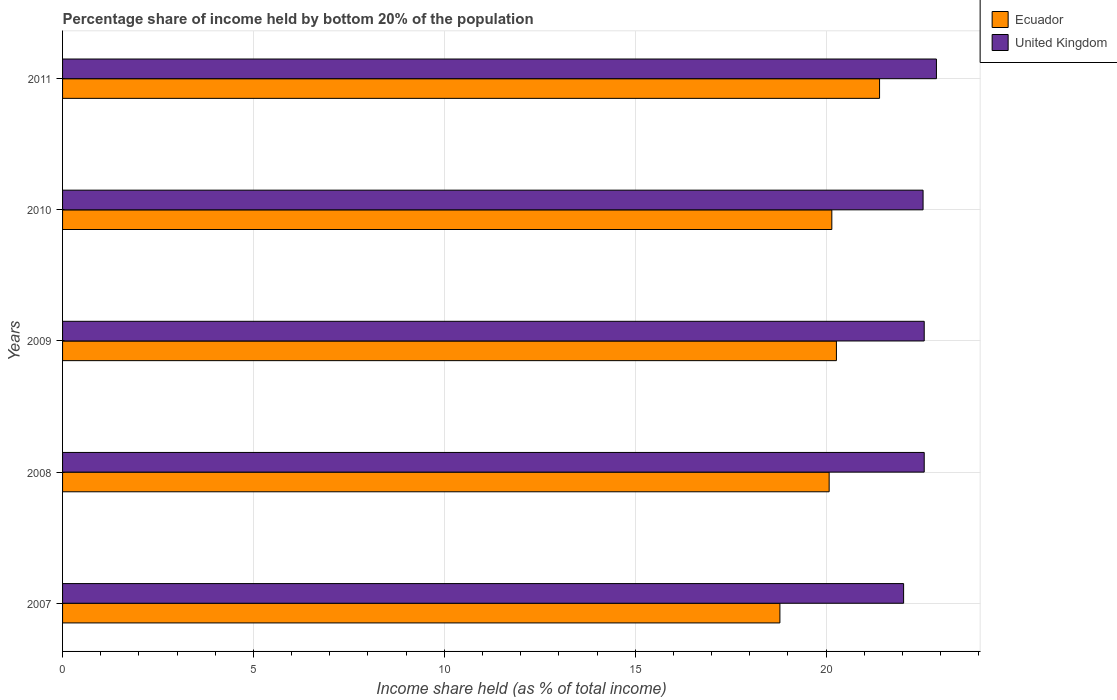How many different coloured bars are there?
Provide a succinct answer. 2. How many groups of bars are there?
Your answer should be compact. 5. How many bars are there on the 5th tick from the top?
Your response must be concise. 2. How many bars are there on the 2nd tick from the bottom?
Your response must be concise. 2. What is the label of the 3rd group of bars from the top?
Make the answer very short. 2009. In how many cases, is the number of bars for a given year not equal to the number of legend labels?
Your answer should be very brief. 0. What is the share of income held by bottom 20% of the population in Ecuador in 2009?
Provide a succinct answer. 20.27. Across all years, what is the maximum share of income held by bottom 20% of the population in Ecuador?
Give a very brief answer. 21.4. Across all years, what is the minimum share of income held by bottom 20% of the population in United Kingdom?
Give a very brief answer. 22.03. In which year was the share of income held by bottom 20% of the population in Ecuador maximum?
Give a very brief answer. 2011. What is the total share of income held by bottom 20% of the population in United Kingdom in the graph?
Provide a succinct answer. 112.6. What is the difference between the share of income held by bottom 20% of the population in United Kingdom in 2008 and that in 2011?
Offer a terse response. -0.32. What is the difference between the share of income held by bottom 20% of the population in Ecuador in 2010 and the share of income held by bottom 20% of the population in United Kingdom in 2011?
Ensure brevity in your answer.  -2.74. What is the average share of income held by bottom 20% of the population in Ecuador per year?
Your answer should be very brief. 20.14. In the year 2009, what is the difference between the share of income held by bottom 20% of the population in Ecuador and share of income held by bottom 20% of the population in United Kingdom?
Your answer should be very brief. -2.3. In how many years, is the share of income held by bottom 20% of the population in Ecuador greater than 22 %?
Your response must be concise. 0. What is the ratio of the share of income held by bottom 20% of the population in Ecuador in 2009 to that in 2011?
Offer a terse response. 0.95. What is the difference between the highest and the second highest share of income held by bottom 20% of the population in United Kingdom?
Provide a short and direct response. 0.32. What is the difference between the highest and the lowest share of income held by bottom 20% of the population in United Kingdom?
Give a very brief answer. 0.86. Is the sum of the share of income held by bottom 20% of the population in United Kingdom in 2009 and 2011 greater than the maximum share of income held by bottom 20% of the population in Ecuador across all years?
Offer a very short reply. Yes. What does the 2nd bar from the top in 2011 represents?
Offer a terse response. Ecuador. How many bars are there?
Offer a very short reply. 10. Where does the legend appear in the graph?
Offer a very short reply. Top right. What is the title of the graph?
Your answer should be compact. Percentage share of income held by bottom 20% of the population. What is the label or title of the X-axis?
Keep it short and to the point. Income share held (as % of total income). What is the Income share held (as % of total income) of Ecuador in 2007?
Provide a short and direct response. 18.79. What is the Income share held (as % of total income) of United Kingdom in 2007?
Provide a short and direct response. 22.03. What is the Income share held (as % of total income) of Ecuador in 2008?
Provide a succinct answer. 20.08. What is the Income share held (as % of total income) in United Kingdom in 2008?
Ensure brevity in your answer.  22.57. What is the Income share held (as % of total income) in Ecuador in 2009?
Give a very brief answer. 20.27. What is the Income share held (as % of total income) of United Kingdom in 2009?
Provide a succinct answer. 22.57. What is the Income share held (as % of total income) in Ecuador in 2010?
Your response must be concise. 20.15. What is the Income share held (as % of total income) of United Kingdom in 2010?
Provide a short and direct response. 22.54. What is the Income share held (as % of total income) of Ecuador in 2011?
Keep it short and to the point. 21.4. What is the Income share held (as % of total income) of United Kingdom in 2011?
Ensure brevity in your answer.  22.89. Across all years, what is the maximum Income share held (as % of total income) in Ecuador?
Provide a succinct answer. 21.4. Across all years, what is the maximum Income share held (as % of total income) in United Kingdom?
Provide a short and direct response. 22.89. Across all years, what is the minimum Income share held (as % of total income) of Ecuador?
Provide a short and direct response. 18.79. Across all years, what is the minimum Income share held (as % of total income) of United Kingdom?
Give a very brief answer. 22.03. What is the total Income share held (as % of total income) of Ecuador in the graph?
Keep it short and to the point. 100.69. What is the total Income share held (as % of total income) of United Kingdom in the graph?
Offer a terse response. 112.6. What is the difference between the Income share held (as % of total income) of Ecuador in 2007 and that in 2008?
Make the answer very short. -1.29. What is the difference between the Income share held (as % of total income) of United Kingdom in 2007 and that in 2008?
Offer a very short reply. -0.54. What is the difference between the Income share held (as % of total income) of Ecuador in 2007 and that in 2009?
Your response must be concise. -1.48. What is the difference between the Income share held (as % of total income) of United Kingdom in 2007 and that in 2009?
Offer a very short reply. -0.54. What is the difference between the Income share held (as % of total income) in Ecuador in 2007 and that in 2010?
Keep it short and to the point. -1.36. What is the difference between the Income share held (as % of total income) of United Kingdom in 2007 and that in 2010?
Make the answer very short. -0.51. What is the difference between the Income share held (as % of total income) in Ecuador in 2007 and that in 2011?
Your answer should be very brief. -2.61. What is the difference between the Income share held (as % of total income) in United Kingdom in 2007 and that in 2011?
Make the answer very short. -0.86. What is the difference between the Income share held (as % of total income) in Ecuador in 2008 and that in 2009?
Make the answer very short. -0.19. What is the difference between the Income share held (as % of total income) of Ecuador in 2008 and that in 2010?
Ensure brevity in your answer.  -0.07. What is the difference between the Income share held (as % of total income) in Ecuador in 2008 and that in 2011?
Make the answer very short. -1.32. What is the difference between the Income share held (as % of total income) of United Kingdom in 2008 and that in 2011?
Provide a short and direct response. -0.32. What is the difference between the Income share held (as % of total income) of Ecuador in 2009 and that in 2010?
Offer a terse response. 0.12. What is the difference between the Income share held (as % of total income) of United Kingdom in 2009 and that in 2010?
Provide a succinct answer. 0.03. What is the difference between the Income share held (as % of total income) of Ecuador in 2009 and that in 2011?
Ensure brevity in your answer.  -1.13. What is the difference between the Income share held (as % of total income) of United Kingdom in 2009 and that in 2011?
Offer a very short reply. -0.32. What is the difference between the Income share held (as % of total income) in Ecuador in 2010 and that in 2011?
Keep it short and to the point. -1.25. What is the difference between the Income share held (as % of total income) in United Kingdom in 2010 and that in 2011?
Make the answer very short. -0.35. What is the difference between the Income share held (as % of total income) of Ecuador in 2007 and the Income share held (as % of total income) of United Kingdom in 2008?
Your answer should be very brief. -3.78. What is the difference between the Income share held (as % of total income) in Ecuador in 2007 and the Income share held (as % of total income) in United Kingdom in 2009?
Keep it short and to the point. -3.78. What is the difference between the Income share held (as % of total income) in Ecuador in 2007 and the Income share held (as % of total income) in United Kingdom in 2010?
Offer a very short reply. -3.75. What is the difference between the Income share held (as % of total income) in Ecuador in 2007 and the Income share held (as % of total income) in United Kingdom in 2011?
Give a very brief answer. -4.1. What is the difference between the Income share held (as % of total income) of Ecuador in 2008 and the Income share held (as % of total income) of United Kingdom in 2009?
Your answer should be very brief. -2.49. What is the difference between the Income share held (as % of total income) of Ecuador in 2008 and the Income share held (as % of total income) of United Kingdom in 2010?
Your answer should be compact. -2.46. What is the difference between the Income share held (as % of total income) in Ecuador in 2008 and the Income share held (as % of total income) in United Kingdom in 2011?
Your response must be concise. -2.81. What is the difference between the Income share held (as % of total income) in Ecuador in 2009 and the Income share held (as % of total income) in United Kingdom in 2010?
Your answer should be very brief. -2.27. What is the difference between the Income share held (as % of total income) of Ecuador in 2009 and the Income share held (as % of total income) of United Kingdom in 2011?
Your answer should be very brief. -2.62. What is the difference between the Income share held (as % of total income) of Ecuador in 2010 and the Income share held (as % of total income) of United Kingdom in 2011?
Keep it short and to the point. -2.74. What is the average Income share held (as % of total income) of Ecuador per year?
Your answer should be compact. 20.14. What is the average Income share held (as % of total income) in United Kingdom per year?
Your answer should be very brief. 22.52. In the year 2007, what is the difference between the Income share held (as % of total income) in Ecuador and Income share held (as % of total income) in United Kingdom?
Your response must be concise. -3.24. In the year 2008, what is the difference between the Income share held (as % of total income) in Ecuador and Income share held (as % of total income) in United Kingdom?
Your answer should be compact. -2.49. In the year 2010, what is the difference between the Income share held (as % of total income) in Ecuador and Income share held (as % of total income) in United Kingdom?
Offer a very short reply. -2.39. In the year 2011, what is the difference between the Income share held (as % of total income) of Ecuador and Income share held (as % of total income) of United Kingdom?
Your response must be concise. -1.49. What is the ratio of the Income share held (as % of total income) of Ecuador in 2007 to that in 2008?
Provide a short and direct response. 0.94. What is the ratio of the Income share held (as % of total income) of United Kingdom in 2007 to that in 2008?
Give a very brief answer. 0.98. What is the ratio of the Income share held (as % of total income) of Ecuador in 2007 to that in 2009?
Ensure brevity in your answer.  0.93. What is the ratio of the Income share held (as % of total income) in United Kingdom in 2007 to that in 2009?
Make the answer very short. 0.98. What is the ratio of the Income share held (as % of total income) of Ecuador in 2007 to that in 2010?
Offer a terse response. 0.93. What is the ratio of the Income share held (as % of total income) in United Kingdom in 2007 to that in 2010?
Provide a succinct answer. 0.98. What is the ratio of the Income share held (as % of total income) in Ecuador in 2007 to that in 2011?
Your answer should be compact. 0.88. What is the ratio of the Income share held (as % of total income) in United Kingdom in 2007 to that in 2011?
Make the answer very short. 0.96. What is the ratio of the Income share held (as % of total income) in Ecuador in 2008 to that in 2009?
Offer a very short reply. 0.99. What is the ratio of the Income share held (as % of total income) in United Kingdom in 2008 to that in 2009?
Ensure brevity in your answer.  1. What is the ratio of the Income share held (as % of total income) of Ecuador in 2008 to that in 2011?
Keep it short and to the point. 0.94. What is the ratio of the Income share held (as % of total income) in Ecuador in 2009 to that in 2010?
Provide a short and direct response. 1.01. What is the ratio of the Income share held (as % of total income) in Ecuador in 2009 to that in 2011?
Your response must be concise. 0.95. What is the ratio of the Income share held (as % of total income) in United Kingdom in 2009 to that in 2011?
Provide a short and direct response. 0.99. What is the ratio of the Income share held (as % of total income) in Ecuador in 2010 to that in 2011?
Provide a short and direct response. 0.94. What is the ratio of the Income share held (as % of total income) in United Kingdom in 2010 to that in 2011?
Offer a very short reply. 0.98. What is the difference between the highest and the second highest Income share held (as % of total income) in Ecuador?
Ensure brevity in your answer.  1.13. What is the difference between the highest and the second highest Income share held (as % of total income) of United Kingdom?
Give a very brief answer. 0.32. What is the difference between the highest and the lowest Income share held (as % of total income) of Ecuador?
Your response must be concise. 2.61. What is the difference between the highest and the lowest Income share held (as % of total income) of United Kingdom?
Your answer should be compact. 0.86. 